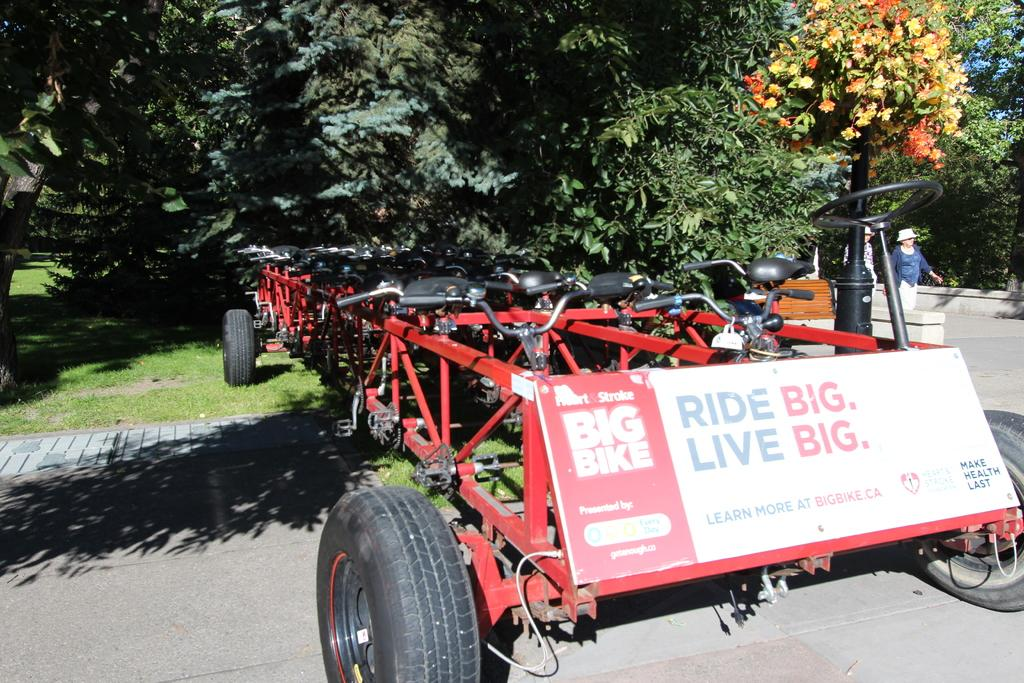What is the main object in the center of the image? There is a board in the center of the image. What else can be seen in the image besides the board? There are vehicles, trees, people, a bench, and a plant in the background of the image. What is the surface on which the board and other objects are placed? There is a floor at the bottom of the image. What is the mass of the plant in the image? It is not possible to determine the mass of the plant in the image from the given information. 